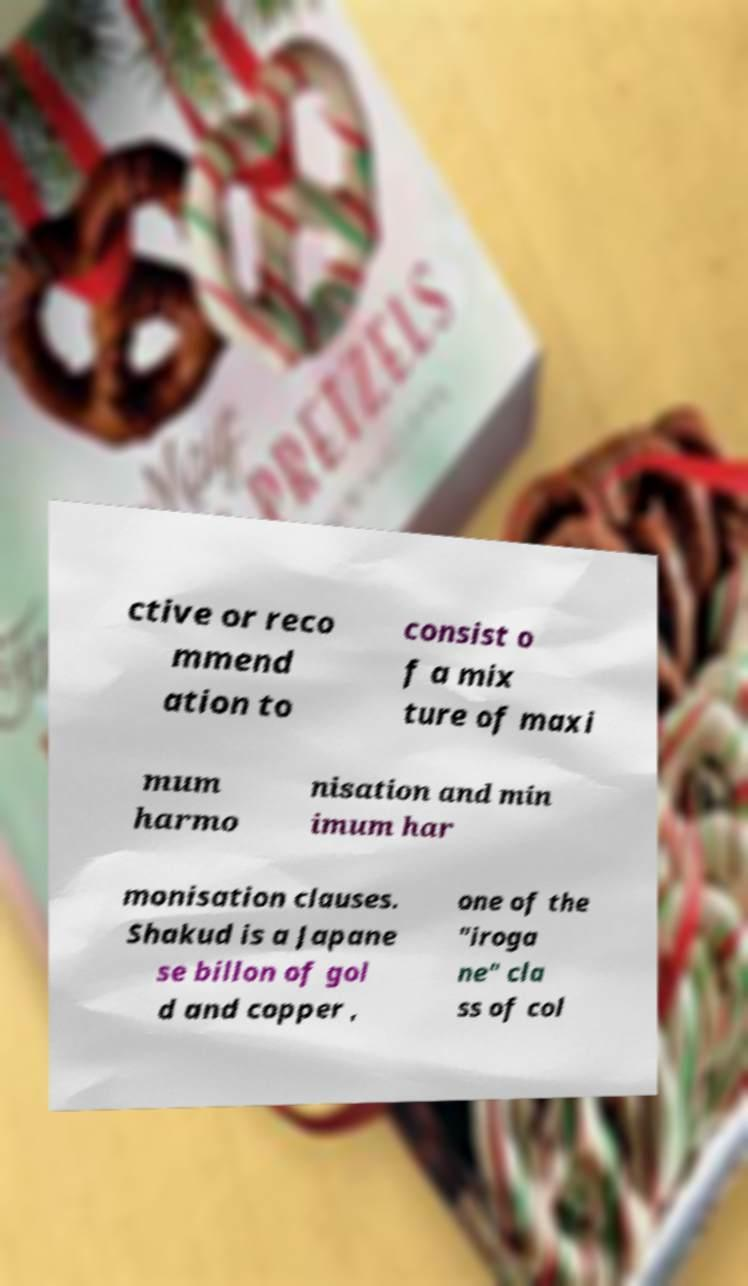Please read and relay the text visible in this image. What does it say? ctive or reco mmend ation to consist o f a mix ture of maxi mum harmo nisation and min imum har monisation clauses. Shakud is a Japane se billon of gol d and copper , one of the "iroga ne" cla ss of col 